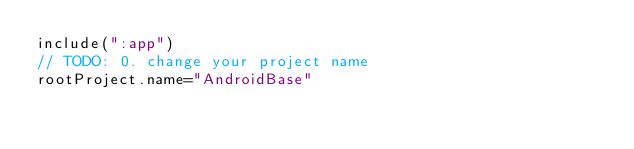<code> <loc_0><loc_0><loc_500><loc_500><_Kotlin_>include(":app")
// TODO: 0. change your project name
rootProject.name="AndroidBase"
</code> 